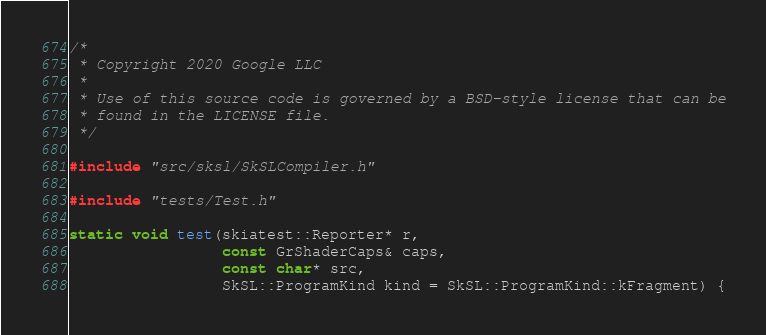Convert code to text. <code><loc_0><loc_0><loc_500><loc_500><_C++_>/*
 * Copyright 2020 Google LLC
 *
 * Use of this source code is governed by a BSD-style license that can be
 * found in the LICENSE file.
 */

#include "src/sksl/SkSLCompiler.h"

#include "tests/Test.h"

static void test(skiatest::Reporter* r,
                 const GrShaderCaps& caps,
                 const char* src,
                 SkSL::ProgramKind kind = SkSL::ProgramKind::kFragment) {</code> 